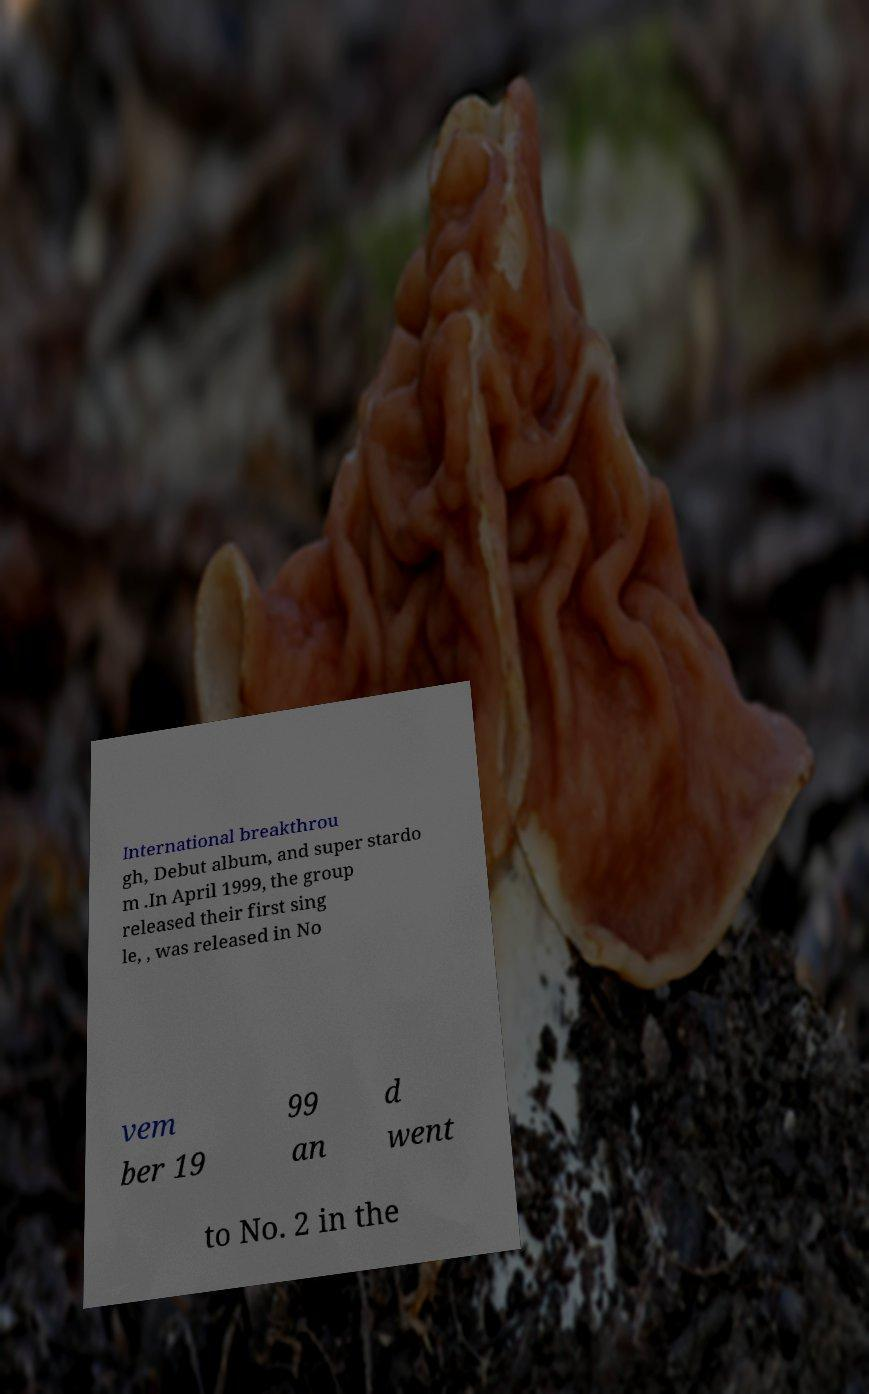Please identify and transcribe the text found in this image. International breakthrou gh, Debut album, and super stardo m .In April 1999, the group released their first sing le, , was released in No vem ber 19 99 an d went to No. 2 in the 